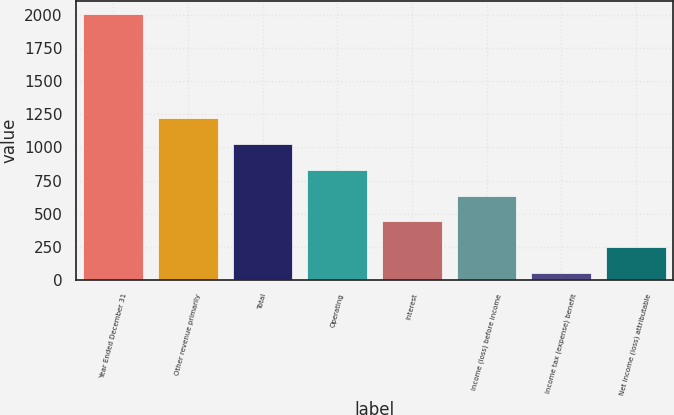Convert chart to OTSL. <chart><loc_0><loc_0><loc_500><loc_500><bar_chart><fcel>Year Ended December 31<fcel>Other revenue primarily<fcel>Total<fcel>Operating<fcel>Interest<fcel>Income (loss) before income<fcel>Income tax (expense) benefit<fcel>Net income (loss) attributable<nl><fcel>2010<fcel>1225.2<fcel>1029<fcel>832.8<fcel>440.4<fcel>636.6<fcel>48<fcel>244.2<nl></chart> 